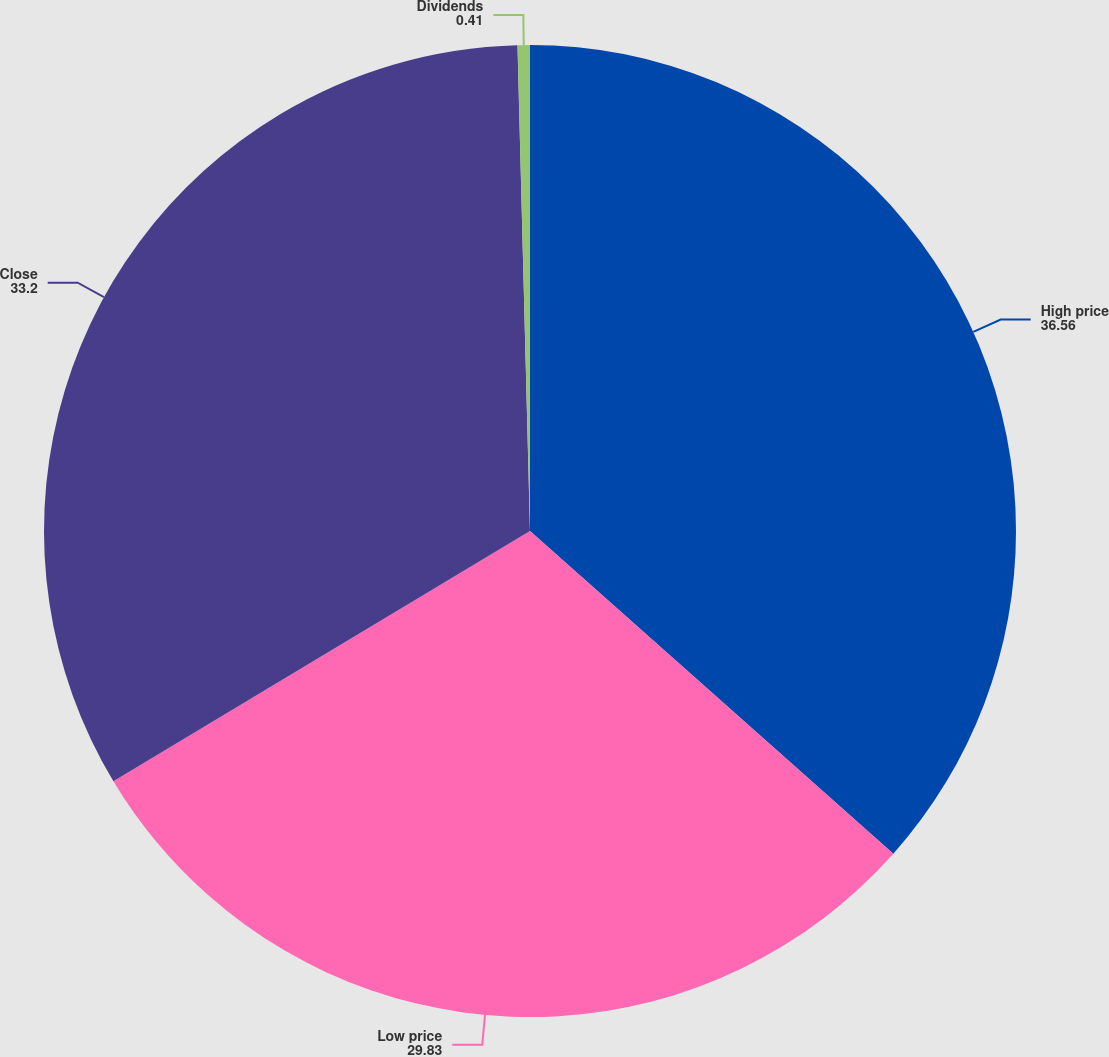<chart> <loc_0><loc_0><loc_500><loc_500><pie_chart><fcel>High price<fcel>Low price<fcel>Close<fcel>Dividends<nl><fcel>36.56%<fcel>29.83%<fcel>33.2%<fcel>0.41%<nl></chart> 